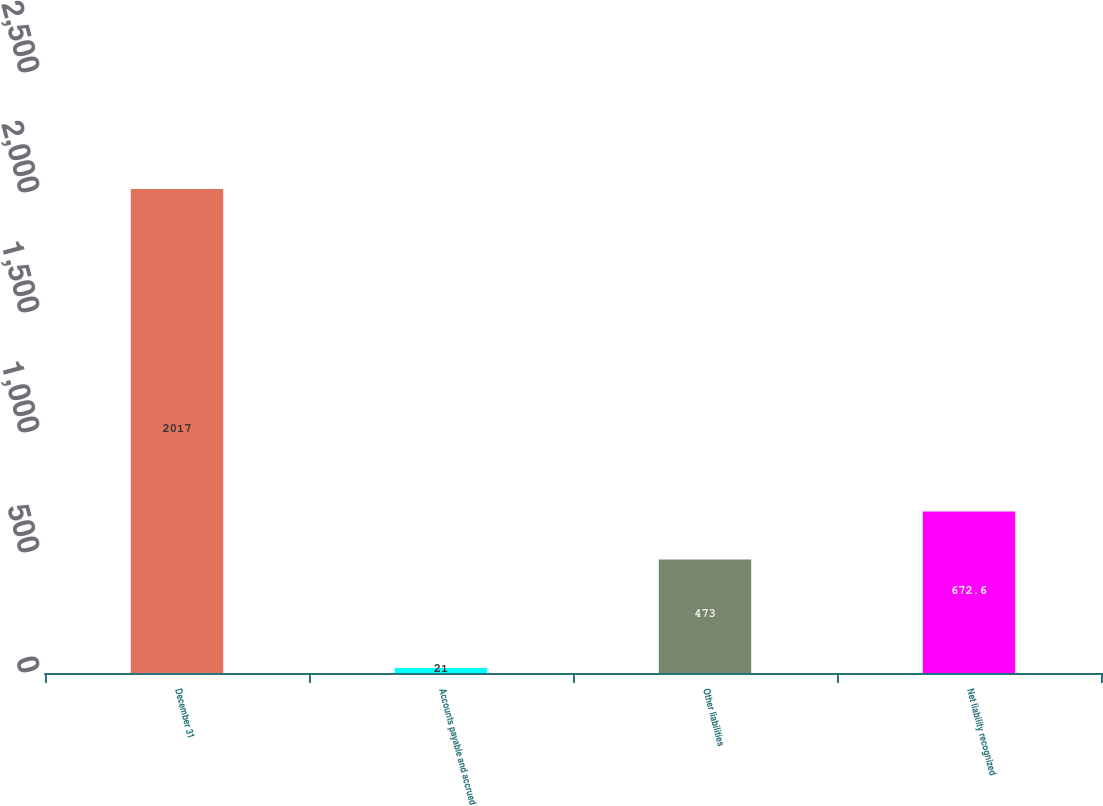<chart> <loc_0><loc_0><loc_500><loc_500><bar_chart><fcel>December 31<fcel>Accounts payable and accrued<fcel>Other liabilities<fcel>Net liability recognized<nl><fcel>2017<fcel>21<fcel>473<fcel>672.6<nl></chart> 